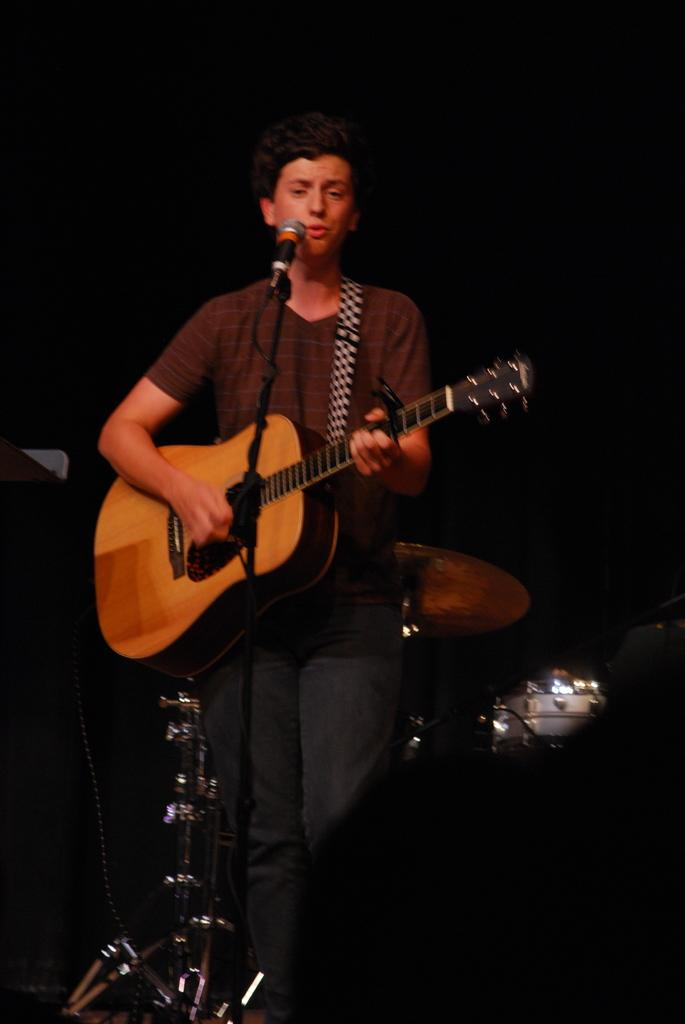What is the man in the image doing? The man is playing a guitar in the image. What object is present in the image that is typically used for amplifying sound? There is a microphone (mike) in the image. What type of coach can be seen in the image? There is no coach present in the image. What type of friction is being generated by the man's guitar playing in the image? The image does not provide information about the friction generated by the man's guitar playing. 